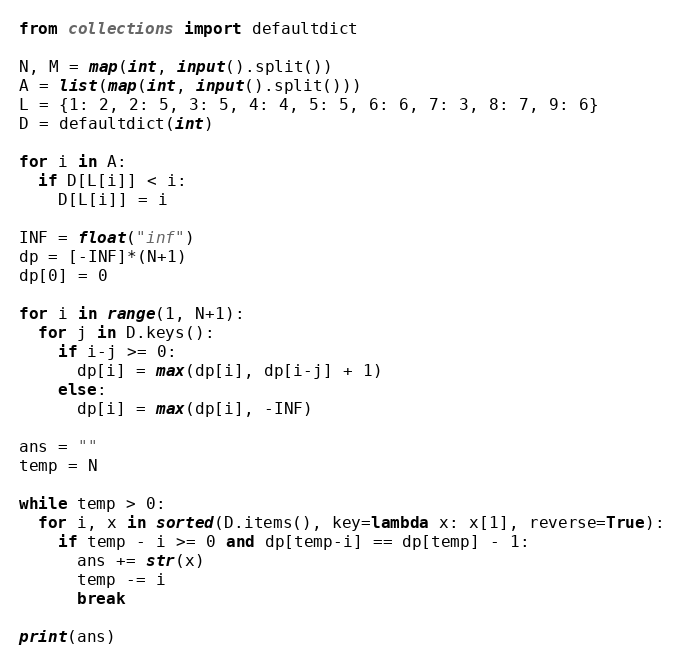Convert code to text. <code><loc_0><loc_0><loc_500><loc_500><_Python_>from collections import defaultdict

N, M = map(int, input().split())
A = list(map(int, input().split()))
L = {1: 2, 2: 5, 3: 5, 4: 4, 5: 5, 6: 6, 7: 3, 8: 7, 9: 6}
D = defaultdict(int)

for i in A:
  if D[L[i]] < i:
    D[L[i]] = i

INF = float("inf")
dp = [-INF]*(N+1)
dp[0] = 0

for i in range(1, N+1):
  for j in D.keys():
    if i-j >= 0:
      dp[i] = max(dp[i], dp[i-j] + 1)
    else:
      dp[i] = max(dp[i], -INF)

ans = ""
temp = N

while temp > 0:
  for i, x in sorted(D.items(), key=lambda x: x[1], reverse=True):
    if temp - i >= 0 and dp[temp-i] == dp[temp] - 1:
      ans += str(x)
      temp -= i
      break

print(ans)</code> 